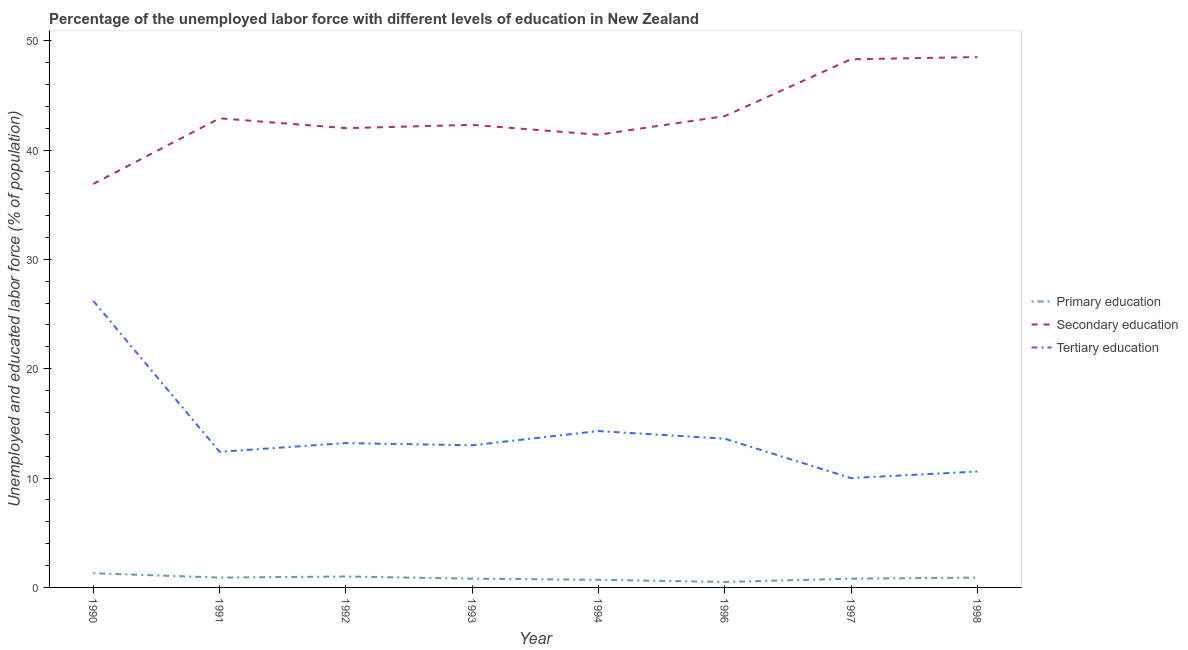Does the line corresponding to percentage of labor force who received primary education intersect with the line corresponding to percentage of labor force who received tertiary education?
Offer a very short reply. No. What is the percentage of labor force who received secondary education in 1991?
Your response must be concise. 42.9. Across all years, what is the maximum percentage of labor force who received tertiary education?
Keep it short and to the point. 26.2. In which year was the percentage of labor force who received secondary education maximum?
Provide a short and direct response. 1998. What is the total percentage of labor force who received tertiary education in the graph?
Give a very brief answer. 113.3. What is the difference between the percentage of labor force who received primary education in 1993 and that in 1994?
Your answer should be compact. 0.1. What is the difference between the percentage of labor force who received tertiary education in 1991 and the percentage of labor force who received secondary education in 1998?
Provide a short and direct response. -36.1. What is the average percentage of labor force who received tertiary education per year?
Provide a short and direct response. 14.16. In the year 1994, what is the difference between the percentage of labor force who received primary education and percentage of labor force who received tertiary education?
Your answer should be compact. -13.6. In how many years, is the percentage of labor force who received tertiary education greater than 24 %?
Make the answer very short. 1. What is the ratio of the percentage of labor force who received tertiary education in 1991 to that in 1997?
Your answer should be very brief. 1.24. Is the difference between the percentage of labor force who received secondary education in 1992 and 1996 greater than the difference between the percentage of labor force who received tertiary education in 1992 and 1996?
Provide a short and direct response. No. What is the difference between the highest and the second highest percentage of labor force who received primary education?
Ensure brevity in your answer.  0.3. What is the difference between the highest and the lowest percentage of labor force who received tertiary education?
Your answer should be compact. 16.2. Is the sum of the percentage of labor force who received tertiary education in 1992 and 1997 greater than the maximum percentage of labor force who received secondary education across all years?
Give a very brief answer. No. Does the percentage of labor force who received tertiary education monotonically increase over the years?
Your answer should be very brief. No. Is the percentage of labor force who received tertiary education strictly less than the percentage of labor force who received secondary education over the years?
Your answer should be very brief. Yes. How many years are there in the graph?
Your answer should be very brief. 8. What is the difference between two consecutive major ticks on the Y-axis?
Give a very brief answer. 10. Are the values on the major ticks of Y-axis written in scientific E-notation?
Offer a terse response. No. Does the graph contain grids?
Your answer should be very brief. No. How are the legend labels stacked?
Give a very brief answer. Vertical. What is the title of the graph?
Your response must be concise. Percentage of the unemployed labor force with different levels of education in New Zealand. Does "Errors" appear as one of the legend labels in the graph?
Provide a short and direct response. No. What is the label or title of the Y-axis?
Offer a very short reply. Unemployed and educated labor force (% of population). What is the Unemployed and educated labor force (% of population) of Primary education in 1990?
Give a very brief answer. 1.3. What is the Unemployed and educated labor force (% of population) in Secondary education in 1990?
Offer a terse response. 36.9. What is the Unemployed and educated labor force (% of population) in Tertiary education in 1990?
Offer a very short reply. 26.2. What is the Unemployed and educated labor force (% of population) of Primary education in 1991?
Ensure brevity in your answer.  0.9. What is the Unemployed and educated labor force (% of population) in Secondary education in 1991?
Make the answer very short. 42.9. What is the Unemployed and educated labor force (% of population) of Tertiary education in 1991?
Keep it short and to the point. 12.4. What is the Unemployed and educated labor force (% of population) of Primary education in 1992?
Give a very brief answer. 1. What is the Unemployed and educated labor force (% of population) of Tertiary education in 1992?
Provide a succinct answer. 13.2. What is the Unemployed and educated labor force (% of population) in Primary education in 1993?
Give a very brief answer. 0.8. What is the Unemployed and educated labor force (% of population) of Secondary education in 1993?
Your answer should be compact. 42.3. What is the Unemployed and educated labor force (% of population) of Tertiary education in 1993?
Offer a terse response. 13. What is the Unemployed and educated labor force (% of population) in Primary education in 1994?
Make the answer very short. 0.7. What is the Unemployed and educated labor force (% of population) in Secondary education in 1994?
Your response must be concise. 41.4. What is the Unemployed and educated labor force (% of population) of Tertiary education in 1994?
Give a very brief answer. 14.3. What is the Unemployed and educated labor force (% of population) in Secondary education in 1996?
Offer a terse response. 43.1. What is the Unemployed and educated labor force (% of population) in Tertiary education in 1996?
Make the answer very short. 13.6. What is the Unemployed and educated labor force (% of population) of Primary education in 1997?
Your response must be concise. 0.8. What is the Unemployed and educated labor force (% of population) in Secondary education in 1997?
Provide a short and direct response. 48.3. What is the Unemployed and educated labor force (% of population) in Tertiary education in 1997?
Keep it short and to the point. 10. What is the Unemployed and educated labor force (% of population) in Primary education in 1998?
Your answer should be very brief. 0.9. What is the Unemployed and educated labor force (% of population) of Secondary education in 1998?
Your answer should be compact. 48.5. What is the Unemployed and educated labor force (% of population) of Tertiary education in 1998?
Give a very brief answer. 10.6. Across all years, what is the maximum Unemployed and educated labor force (% of population) in Primary education?
Your answer should be compact. 1.3. Across all years, what is the maximum Unemployed and educated labor force (% of population) of Secondary education?
Make the answer very short. 48.5. Across all years, what is the maximum Unemployed and educated labor force (% of population) of Tertiary education?
Your response must be concise. 26.2. Across all years, what is the minimum Unemployed and educated labor force (% of population) in Primary education?
Provide a succinct answer. 0.5. Across all years, what is the minimum Unemployed and educated labor force (% of population) of Secondary education?
Give a very brief answer. 36.9. What is the total Unemployed and educated labor force (% of population) in Secondary education in the graph?
Your answer should be very brief. 345.4. What is the total Unemployed and educated labor force (% of population) of Tertiary education in the graph?
Your response must be concise. 113.3. What is the difference between the Unemployed and educated labor force (% of population) in Secondary education in 1990 and that in 1991?
Your answer should be compact. -6. What is the difference between the Unemployed and educated labor force (% of population) in Secondary education in 1990 and that in 1992?
Provide a succinct answer. -5.1. What is the difference between the Unemployed and educated labor force (% of population) of Primary education in 1990 and that in 1993?
Make the answer very short. 0.5. What is the difference between the Unemployed and educated labor force (% of population) in Secondary education in 1990 and that in 1993?
Provide a succinct answer. -5.4. What is the difference between the Unemployed and educated labor force (% of population) of Secondary education in 1990 and that in 1994?
Ensure brevity in your answer.  -4.5. What is the difference between the Unemployed and educated labor force (% of population) of Tertiary education in 1990 and that in 1994?
Your answer should be very brief. 11.9. What is the difference between the Unemployed and educated labor force (% of population) of Tertiary education in 1990 and that in 1997?
Make the answer very short. 16.2. What is the difference between the Unemployed and educated labor force (% of population) in Primary education in 1991 and that in 1992?
Your response must be concise. -0.1. What is the difference between the Unemployed and educated labor force (% of population) of Secondary education in 1991 and that in 1992?
Make the answer very short. 0.9. What is the difference between the Unemployed and educated labor force (% of population) of Primary education in 1991 and that in 1994?
Ensure brevity in your answer.  0.2. What is the difference between the Unemployed and educated labor force (% of population) in Secondary education in 1991 and that in 1994?
Provide a short and direct response. 1.5. What is the difference between the Unemployed and educated labor force (% of population) in Tertiary education in 1991 and that in 1994?
Your answer should be very brief. -1.9. What is the difference between the Unemployed and educated labor force (% of population) of Primary education in 1991 and that in 1996?
Offer a very short reply. 0.4. What is the difference between the Unemployed and educated labor force (% of population) of Primary education in 1991 and that in 1997?
Offer a terse response. 0.1. What is the difference between the Unemployed and educated labor force (% of population) in Secondary education in 1991 and that in 1997?
Provide a short and direct response. -5.4. What is the difference between the Unemployed and educated labor force (% of population) of Tertiary education in 1991 and that in 1997?
Ensure brevity in your answer.  2.4. What is the difference between the Unemployed and educated labor force (% of population) in Primary education in 1991 and that in 1998?
Your answer should be compact. 0. What is the difference between the Unemployed and educated labor force (% of population) in Primary education in 1992 and that in 1993?
Your answer should be very brief. 0.2. What is the difference between the Unemployed and educated labor force (% of population) of Secondary education in 1992 and that in 1993?
Your answer should be very brief. -0.3. What is the difference between the Unemployed and educated labor force (% of population) in Tertiary education in 1992 and that in 1993?
Offer a very short reply. 0.2. What is the difference between the Unemployed and educated labor force (% of population) in Primary education in 1992 and that in 1994?
Your answer should be compact. 0.3. What is the difference between the Unemployed and educated labor force (% of population) in Tertiary education in 1992 and that in 1994?
Make the answer very short. -1.1. What is the difference between the Unemployed and educated labor force (% of population) in Tertiary education in 1992 and that in 1996?
Your response must be concise. -0.4. What is the difference between the Unemployed and educated labor force (% of population) of Primary education in 1992 and that in 1997?
Your answer should be compact. 0.2. What is the difference between the Unemployed and educated labor force (% of population) in Secondary education in 1992 and that in 1997?
Provide a short and direct response. -6.3. What is the difference between the Unemployed and educated labor force (% of population) in Tertiary education in 1992 and that in 1997?
Your response must be concise. 3.2. What is the difference between the Unemployed and educated labor force (% of population) of Tertiary education in 1992 and that in 1998?
Keep it short and to the point. 2.6. What is the difference between the Unemployed and educated labor force (% of population) in Primary education in 1993 and that in 1994?
Your answer should be compact. 0.1. What is the difference between the Unemployed and educated labor force (% of population) in Primary education in 1993 and that in 1996?
Your answer should be very brief. 0.3. What is the difference between the Unemployed and educated labor force (% of population) in Secondary education in 1993 and that in 1996?
Give a very brief answer. -0.8. What is the difference between the Unemployed and educated labor force (% of population) of Tertiary education in 1993 and that in 1996?
Give a very brief answer. -0.6. What is the difference between the Unemployed and educated labor force (% of population) of Tertiary education in 1993 and that in 1998?
Provide a succinct answer. 2.4. What is the difference between the Unemployed and educated labor force (% of population) in Primary education in 1994 and that in 1996?
Your answer should be compact. 0.2. What is the difference between the Unemployed and educated labor force (% of population) of Tertiary education in 1994 and that in 1996?
Provide a short and direct response. 0.7. What is the difference between the Unemployed and educated labor force (% of population) in Secondary education in 1994 and that in 1997?
Your response must be concise. -6.9. What is the difference between the Unemployed and educated labor force (% of population) in Primary education in 1996 and that in 1997?
Offer a terse response. -0.3. What is the difference between the Unemployed and educated labor force (% of population) in Tertiary education in 1996 and that in 1997?
Offer a very short reply. 3.6. What is the difference between the Unemployed and educated labor force (% of population) in Primary education in 1996 and that in 1998?
Offer a terse response. -0.4. What is the difference between the Unemployed and educated labor force (% of population) in Secondary education in 1997 and that in 1998?
Provide a succinct answer. -0.2. What is the difference between the Unemployed and educated labor force (% of population) of Tertiary education in 1997 and that in 1998?
Keep it short and to the point. -0.6. What is the difference between the Unemployed and educated labor force (% of population) of Primary education in 1990 and the Unemployed and educated labor force (% of population) of Secondary education in 1991?
Your answer should be compact. -41.6. What is the difference between the Unemployed and educated labor force (% of population) of Primary education in 1990 and the Unemployed and educated labor force (% of population) of Secondary education in 1992?
Ensure brevity in your answer.  -40.7. What is the difference between the Unemployed and educated labor force (% of population) in Primary education in 1990 and the Unemployed and educated labor force (% of population) in Tertiary education in 1992?
Your answer should be very brief. -11.9. What is the difference between the Unemployed and educated labor force (% of population) in Secondary education in 1990 and the Unemployed and educated labor force (% of population) in Tertiary education in 1992?
Offer a very short reply. 23.7. What is the difference between the Unemployed and educated labor force (% of population) of Primary education in 1990 and the Unemployed and educated labor force (% of population) of Secondary education in 1993?
Provide a succinct answer. -41. What is the difference between the Unemployed and educated labor force (% of population) of Secondary education in 1990 and the Unemployed and educated labor force (% of population) of Tertiary education in 1993?
Make the answer very short. 23.9. What is the difference between the Unemployed and educated labor force (% of population) in Primary education in 1990 and the Unemployed and educated labor force (% of population) in Secondary education in 1994?
Keep it short and to the point. -40.1. What is the difference between the Unemployed and educated labor force (% of population) in Secondary education in 1990 and the Unemployed and educated labor force (% of population) in Tertiary education in 1994?
Offer a terse response. 22.6. What is the difference between the Unemployed and educated labor force (% of population) of Primary education in 1990 and the Unemployed and educated labor force (% of population) of Secondary education in 1996?
Keep it short and to the point. -41.8. What is the difference between the Unemployed and educated labor force (% of population) of Secondary education in 1990 and the Unemployed and educated labor force (% of population) of Tertiary education in 1996?
Your answer should be very brief. 23.3. What is the difference between the Unemployed and educated labor force (% of population) in Primary education in 1990 and the Unemployed and educated labor force (% of population) in Secondary education in 1997?
Provide a short and direct response. -47. What is the difference between the Unemployed and educated labor force (% of population) in Primary education in 1990 and the Unemployed and educated labor force (% of population) in Tertiary education in 1997?
Your response must be concise. -8.7. What is the difference between the Unemployed and educated labor force (% of population) in Secondary education in 1990 and the Unemployed and educated labor force (% of population) in Tertiary education in 1997?
Ensure brevity in your answer.  26.9. What is the difference between the Unemployed and educated labor force (% of population) of Primary education in 1990 and the Unemployed and educated labor force (% of population) of Secondary education in 1998?
Keep it short and to the point. -47.2. What is the difference between the Unemployed and educated labor force (% of population) of Primary education in 1990 and the Unemployed and educated labor force (% of population) of Tertiary education in 1998?
Ensure brevity in your answer.  -9.3. What is the difference between the Unemployed and educated labor force (% of population) in Secondary education in 1990 and the Unemployed and educated labor force (% of population) in Tertiary education in 1998?
Provide a succinct answer. 26.3. What is the difference between the Unemployed and educated labor force (% of population) of Primary education in 1991 and the Unemployed and educated labor force (% of population) of Secondary education in 1992?
Give a very brief answer. -41.1. What is the difference between the Unemployed and educated labor force (% of population) in Primary education in 1991 and the Unemployed and educated labor force (% of population) in Tertiary education in 1992?
Offer a terse response. -12.3. What is the difference between the Unemployed and educated labor force (% of population) of Secondary education in 1991 and the Unemployed and educated labor force (% of population) of Tertiary education in 1992?
Your answer should be very brief. 29.7. What is the difference between the Unemployed and educated labor force (% of population) in Primary education in 1991 and the Unemployed and educated labor force (% of population) in Secondary education in 1993?
Give a very brief answer. -41.4. What is the difference between the Unemployed and educated labor force (% of population) of Secondary education in 1991 and the Unemployed and educated labor force (% of population) of Tertiary education in 1993?
Provide a short and direct response. 29.9. What is the difference between the Unemployed and educated labor force (% of population) of Primary education in 1991 and the Unemployed and educated labor force (% of population) of Secondary education in 1994?
Make the answer very short. -40.5. What is the difference between the Unemployed and educated labor force (% of population) of Secondary education in 1991 and the Unemployed and educated labor force (% of population) of Tertiary education in 1994?
Give a very brief answer. 28.6. What is the difference between the Unemployed and educated labor force (% of population) of Primary education in 1991 and the Unemployed and educated labor force (% of population) of Secondary education in 1996?
Your answer should be compact. -42.2. What is the difference between the Unemployed and educated labor force (% of population) of Primary education in 1991 and the Unemployed and educated labor force (% of population) of Tertiary education in 1996?
Offer a very short reply. -12.7. What is the difference between the Unemployed and educated labor force (% of population) of Secondary education in 1991 and the Unemployed and educated labor force (% of population) of Tertiary education in 1996?
Give a very brief answer. 29.3. What is the difference between the Unemployed and educated labor force (% of population) in Primary education in 1991 and the Unemployed and educated labor force (% of population) in Secondary education in 1997?
Offer a terse response. -47.4. What is the difference between the Unemployed and educated labor force (% of population) in Secondary education in 1991 and the Unemployed and educated labor force (% of population) in Tertiary education in 1997?
Your answer should be compact. 32.9. What is the difference between the Unemployed and educated labor force (% of population) of Primary education in 1991 and the Unemployed and educated labor force (% of population) of Secondary education in 1998?
Provide a short and direct response. -47.6. What is the difference between the Unemployed and educated labor force (% of population) in Primary education in 1991 and the Unemployed and educated labor force (% of population) in Tertiary education in 1998?
Your answer should be very brief. -9.7. What is the difference between the Unemployed and educated labor force (% of population) in Secondary education in 1991 and the Unemployed and educated labor force (% of population) in Tertiary education in 1998?
Provide a succinct answer. 32.3. What is the difference between the Unemployed and educated labor force (% of population) of Primary education in 1992 and the Unemployed and educated labor force (% of population) of Secondary education in 1993?
Your answer should be compact. -41.3. What is the difference between the Unemployed and educated labor force (% of population) in Primary education in 1992 and the Unemployed and educated labor force (% of population) in Tertiary education in 1993?
Provide a short and direct response. -12. What is the difference between the Unemployed and educated labor force (% of population) of Secondary education in 1992 and the Unemployed and educated labor force (% of population) of Tertiary education in 1993?
Make the answer very short. 29. What is the difference between the Unemployed and educated labor force (% of population) in Primary education in 1992 and the Unemployed and educated labor force (% of population) in Secondary education in 1994?
Offer a very short reply. -40.4. What is the difference between the Unemployed and educated labor force (% of population) of Secondary education in 1992 and the Unemployed and educated labor force (% of population) of Tertiary education in 1994?
Keep it short and to the point. 27.7. What is the difference between the Unemployed and educated labor force (% of population) in Primary education in 1992 and the Unemployed and educated labor force (% of population) in Secondary education in 1996?
Provide a short and direct response. -42.1. What is the difference between the Unemployed and educated labor force (% of population) of Primary education in 1992 and the Unemployed and educated labor force (% of population) of Tertiary education in 1996?
Offer a terse response. -12.6. What is the difference between the Unemployed and educated labor force (% of population) of Secondary education in 1992 and the Unemployed and educated labor force (% of population) of Tertiary education in 1996?
Ensure brevity in your answer.  28.4. What is the difference between the Unemployed and educated labor force (% of population) of Primary education in 1992 and the Unemployed and educated labor force (% of population) of Secondary education in 1997?
Ensure brevity in your answer.  -47.3. What is the difference between the Unemployed and educated labor force (% of population) of Primary education in 1992 and the Unemployed and educated labor force (% of population) of Tertiary education in 1997?
Your answer should be compact. -9. What is the difference between the Unemployed and educated labor force (% of population) of Primary education in 1992 and the Unemployed and educated labor force (% of population) of Secondary education in 1998?
Your answer should be compact. -47.5. What is the difference between the Unemployed and educated labor force (% of population) of Primary education in 1992 and the Unemployed and educated labor force (% of population) of Tertiary education in 1998?
Offer a very short reply. -9.6. What is the difference between the Unemployed and educated labor force (% of population) of Secondary education in 1992 and the Unemployed and educated labor force (% of population) of Tertiary education in 1998?
Offer a very short reply. 31.4. What is the difference between the Unemployed and educated labor force (% of population) in Primary education in 1993 and the Unemployed and educated labor force (% of population) in Secondary education in 1994?
Your answer should be compact. -40.6. What is the difference between the Unemployed and educated labor force (% of population) of Secondary education in 1993 and the Unemployed and educated labor force (% of population) of Tertiary education in 1994?
Offer a very short reply. 28. What is the difference between the Unemployed and educated labor force (% of population) in Primary education in 1993 and the Unemployed and educated labor force (% of population) in Secondary education in 1996?
Ensure brevity in your answer.  -42.3. What is the difference between the Unemployed and educated labor force (% of population) in Primary education in 1993 and the Unemployed and educated labor force (% of population) in Tertiary education in 1996?
Offer a terse response. -12.8. What is the difference between the Unemployed and educated labor force (% of population) in Secondary education in 1993 and the Unemployed and educated labor force (% of population) in Tertiary education in 1996?
Keep it short and to the point. 28.7. What is the difference between the Unemployed and educated labor force (% of population) in Primary education in 1993 and the Unemployed and educated labor force (% of population) in Secondary education in 1997?
Provide a short and direct response. -47.5. What is the difference between the Unemployed and educated labor force (% of population) in Secondary education in 1993 and the Unemployed and educated labor force (% of population) in Tertiary education in 1997?
Provide a short and direct response. 32.3. What is the difference between the Unemployed and educated labor force (% of population) of Primary education in 1993 and the Unemployed and educated labor force (% of population) of Secondary education in 1998?
Ensure brevity in your answer.  -47.7. What is the difference between the Unemployed and educated labor force (% of population) of Secondary education in 1993 and the Unemployed and educated labor force (% of population) of Tertiary education in 1998?
Your answer should be compact. 31.7. What is the difference between the Unemployed and educated labor force (% of population) in Primary education in 1994 and the Unemployed and educated labor force (% of population) in Secondary education in 1996?
Make the answer very short. -42.4. What is the difference between the Unemployed and educated labor force (% of population) of Secondary education in 1994 and the Unemployed and educated labor force (% of population) of Tertiary education in 1996?
Make the answer very short. 27.8. What is the difference between the Unemployed and educated labor force (% of population) of Primary education in 1994 and the Unemployed and educated labor force (% of population) of Secondary education in 1997?
Your answer should be very brief. -47.6. What is the difference between the Unemployed and educated labor force (% of population) of Primary education in 1994 and the Unemployed and educated labor force (% of population) of Tertiary education in 1997?
Offer a terse response. -9.3. What is the difference between the Unemployed and educated labor force (% of population) in Secondary education in 1994 and the Unemployed and educated labor force (% of population) in Tertiary education in 1997?
Offer a terse response. 31.4. What is the difference between the Unemployed and educated labor force (% of population) in Primary education in 1994 and the Unemployed and educated labor force (% of population) in Secondary education in 1998?
Your response must be concise. -47.8. What is the difference between the Unemployed and educated labor force (% of population) of Primary education in 1994 and the Unemployed and educated labor force (% of population) of Tertiary education in 1998?
Provide a succinct answer. -9.9. What is the difference between the Unemployed and educated labor force (% of population) of Secondary education in 1994 and the Unemployed and educated labor force (% of population) of Tertiary education in 1998?
Your response must be concise. 30.8. What is the difference between the Unemployed and educated labor force (% of population) of Primary education in 1996 and the Unemployed and educated labor force (% of population) of Secondary education in 1997?
Your response must be concise. -47.8. What is the difference between the Unemployed and educated labor force (% of population) in Secondary education in 1996 and the Unemployed and educated labor force (% of population) in Tertiary education in 1997?
Your answer should be compact. 33.1. What is the difference between the Unemployed and educated labor force (% of population) in Primary education in 1996 and the Unemployed and educated labor force (% of population) in Secondary education in 1998?
Your response must be concise. -48. What is the difference between the Unemployed and educated labor force (% of population) of Primary education in 1996 and the Unemployed and educated labor force (% of population) of Tertiary education in 1998?
Keep it short and to the point. -10.1. What is the difference between the Unemployed and educated labor force (% of population) in Secondary education in 1996 and the Unemployed and educated labor force (% of population) in Tertiary education in 1998?
Your response must be concise. 32.5. What is the difference between the Unemployed and educated labor force (% of population) in Primary education in 1997 and the Unemployed and educated labor force (% of population) in Secondary education in 1998?
Provide a succinct answer. -47.7. What is the difference between the Unemployed and educated labor force (% of population) of Primary education in 1997 and the Unemployed and educated labor force (% of population) of Tertiary education in 1998?
Offer a terse response. -9.8. What is the difference between the Unemployed and educated labor force (% of population) in Secondary education in 1997 and the Unemployed and educated labor force (% of population) in Tertiary education in 1998?
Your answer should be compact. 37.7. What is the average Unemployed and educated labor force (% of population) in Primary education per year?
Provide a short and direct response. 0.86. What is the average Unemployed and educated labor force (% of population) in Secondary education per year?
Provide a short and direct response. 43.17. What is the average Unemployed and educated labor force (% of population) in Tertiary education per year?
Offer a very short reply. 14.16. In the year 1990, what is the difference between the Unemployed and educated labor force (% of population) of Primary education and Unemployed and educated labor force (% of population) of Secondary education?
Keep it short and to the point. -35.6. In the year 1990, what is the difference between the Unemployed and educated labor force (% of population) in Primary education and Unemployed and educated labor force (% of population) in Tertiary education?
Your answer should be very brief. -24.9. In the year 1990, what is the difference between the Unemployed and educated labor force (% of population) in Secondary education and Unemployed and educated labor force (% of population) in Tertiary education?
Provide a short and direct response. 10.7. In the year 1991, what is the difference between the Unemployed and educated labor force (% of population) of Primary education and Unemployed and educated labor force (% of population) of Secondary education?
Provide a short and direct response. -42. In the year 1991, what is the difference between the Unemployed and educated labor force (% of population) of Primary education and Unemployed and educated labor force (% of population) of Tertiary education?
Make the answer very short. -11.5. In the year 1991, what is the difference between the Unemployed and educated labor force (% of population) in Secondary education and Unemployed and educated labor force (% of population) in Tertiary education?
Keep it short and to the point. 30.5. In the year 1992, what is the difference between the Unemployed and educated labor force (% of population) in Primary education and Unemployed and educated labor force (% of population) in Secondary education?
Your answer should be compact. -41. In the year 1992, what is the difference between the Unemployed and educated labor force (% of population) in Primary education and Unemployed and educated labor force (% of population) in Tertiary education?
Give a very brief answer. -12.2. In the year 1992, what is the difference between the Unemployed and educated labor force (% of population) of Secondary education and Unemployed and educated labor force (% of population) of Tertiary education?
Give a very brief answer. 28.8. In the year 1993, what is the difference between the Unemployed and educated labor force (% of population) in Primary education and Unemployed and educated labor force (% of population) in Secondary education?
Offer a very short reply. -41.5. In the year 1993, what is the difference between the Unemployed and educated labor force (% of population) in Primary education and Unemployed and educated labor force (% of population) in Tertiary education?
Your response must be concise. -12.2. In the year 1993, what is the difference between the Unemployed and educated labor force (% of population) of Secondary education and Unemployed and educated labor force (% of population) of Tertiary education?
Give a very brief answer. 29.3. In the year 1994, what is the difference between the Unemployed and educated labor force (% of population) of Primary education and Unemployed and educated labor force (% of population) of Secondary education?
Offer a very short reply. -40.7. In the year 1994, what is the difference between the Unemployed and educated labor force (% of population) in Secondary education and Unemployed and educated labor force (% of population) in Tertiary education?
Your answer should be very brief. 27.1. In the year 1996, what is the difference between the Unemployed and educated labor force (% of population) of Primary education and Unemployed and educated labor force (% of population) of Secondary education?
Your answer should be compact. -42.6. In the year 1996, what is the difference between the Unemployed and educated labor force (% of population) of Secondary education and Unemployed and educated labor force (% of population) of Tertiary education?
Your response must be concise. 29.5. In the year 1997, what is the difference between the Unemployed and educated labor force (% of population) in Primary education and Unemployed and educated labor force (% of population) in Secondary education?
Offer a terse response. -47.5. In the year 1997, what is the difference between the Unemployed and educated labor force (% of population) in Secondary education and Unemployed and educated labor force (% of population) in Tertiary education?
Make the answer very short. 38.3. In the year 1998, what is the difference between the Unemployed and educated labor force (% of population) of Primary education and Unemployed and educated labor force (% of population) of Secondary education?
Your answer should be compact. -47.6. In the year 1998, what is the difference between the Unemployed and educated labor force (% of population) in Secondary education and Unemployed and educated labor force (% of population) in Tertiary education?
Keep it short and to the point. 37.9. What is the ratio of the Unemployed and educated labor force (% of population) of Primary education in 1990 to that in 1991?
Keep it short and to the point. 1.44. What is the ratio of the Unemployed and educated labor force (% of population) in Secondary education in 1990 to that in 1991?
Your response must be concise. 0.86. What is the ratio of the Unemployed and educated labor force (% of population) in Tertiary education in 1990 to that in 1991?
Keep it short and to the point. 2.11. What is the ratio of the Unemployed and educated labor force (% of population) in Primary education in 1990 to that in 1992?
Your response must be concise. 1.3. What is the ratio of the Unemployed and educated labor force (% of population) of Secondary education in 1990 to that in 1992?
Your answer should be compact. 0.88. What is the ratio of the Unemployed and educated labor force (% of population) in Tertiary education in 1990 to that in 1992?
Your response must be concise. 1.98. What is the ratio of the Unemployed and educated labor force (% of population) of Primary education in 1990 to that in 1993?
Provide a short and direct response. 1.62. What is the ratio of the Unemployed and educated labor force (% of population) in Secondary education in 1990 to that in 1993?
Offer a very short reply. 0.87. What is the ratio of the Unemployed and educated labor force (% of population) in Tertiary education in 1990 to that in 1993?
Your response must be concise. 2.02. What is the ratio of the Unemployed and educated labor force (% of population) of Primary education in 1990 to that in 1994?
Offer a terse response. 1.86. What is the ratio of the Unemployed and educated labor force (% of population) of Secondary education in 1990 to that in 1994?
Your answer should be very brief. 0.89. What is the ratio of the Unemployed and educated labor force (% of population) of Tertiary education in 1990 to that in 1994?
Make the answer very short. 1.83. What is the ratio of the Unemployed and educated labor force (% of population) in Secondary education in 1990 to that in 1996?
Your answer should be compact. 0.86. What is the ratio of the Unemployed and educated labor force (% of population) in Tertiary education in 1990 to that in 1996?
Your response must be concise. 1.93. What is the ratio of the Unemployed and educated labor force (% of population) of Primary education in 1990 to that in 1997?
Offer a very short reply. 1.62. What is the ratio of the Unemployed and educated labor force (% of population) of Secondary education in 1990 to that in 1997?
Your response must be concise. 0.76. What is the ratio of the Unemployed and educated labor force (% of population) of Tertiary education in 1990 to that in 1997?
Offer a very short reply. 2.62. What is the ratio of the Unemployed and educated labor force (% of population) in Primary education in 1990 to that in 1998?
Offer a very short reply. 1.44. What is the ratio of the Unemployed and educated labor force (% of population) in Secondary education in 1990 to that in 1998?
Provide a short and direct response. 0.76. What is the ratio of the Unemployed and educated labor force (% of population) in Tertiary education in 1990 to that in 1998?
Offer a very short reply. 2.47. What is the ratio of the Unemployed and educated labor force (% of population) in Secondary education in 1991 to that in 1992?
Your response must be concise. 1.02. What is the ratio of the Unemployed and educated labor force (% of population) of Tertiary education in 1991 to that in 1992?
Offer a very short reply. 0.94. What is the ratio of the Unemployed and educated labor force (% of population) in Secondary education in 1991 to that in 1993?
Provide a succinct answer. 1.01. What is the ratio of the Unemployed and educated labor force (% of population) in Tertiary education in 1991 to that in 1993?
Your response must be concise. 0.95. What is the ratio of the Unemployed and educated labor force (% of population) of Primary education in 1991 to that in 1994?
Ensure brevity in your answer.  1.29. What is the ratio of the Unemployed and educated labor force (% of population) in Secondary education in 1991 to that in 1994?
Provide a short and direct response. 1.04. What is the ratio of the Unemployed and educated labor force (% of population) in Tertiary education in 1991 to that in 1994?
Make the answer very short. 0.87. What is the ratio of the Unemployed and educated labor force (% of population) in Tertiary education in 1991 to that in 1996?
Offer a terse response. 0.91. What is the ratio of the Unemployed and educated labor force (% of population) in Secondary education in 1991 to that in 1997?
Your response must be concise. 0.89. What is the ratio of the Unemployed and educated labor force (% of population) of Tertiary education in 1991 to that in 1997?
Provide a short and direct response. 1.24. What is the ratio of the Unemployed and educated labor force (% of population) of Primary education in 1991 to that in 1998?
Offer a very short reply. 1. What is the ratio of the Unemployed and educated labor force (% of population) in Secondary education in 1991 to that in 1998?
Offer a terse response. 0.88. What is the ratio of the Unemployed and educated labor force (% of population) of Tertiary education in 1991 to that in 1998?
Your answer should be compact. 1.17. What is the ratio of the Unemployed and educated labor force (% of population) of Primary education in 1992 to that in 1993?
Your response must be concise. 1.25. What is the ratio of the Unemployed and educated labor force (% of population) in Secondary education in 1992 to that in 1993?
Provide a succinct answer. 0.99. What is the ratio of the Unemployed and educated labor force (% of population) in Tertiary education in 1992 to that in 1993?
Give a very brief answer. 1.02. What is the ratio of the Unemployed and educated labor force (% of population) of Primary education in 1992 to that in 1994?
Offer a very short reply. 1.43. What is the ratio of the Unemployed and educated labor force (% of population) of Secondary education in 1992 to that in 1994?
Provide a succinct answer. 1.01. What is the ratio of the Unemployed and educated labor force (% of population) of Tertiary education in 1992 to that in 1994?
Provide a short and direct response. 0.92. What is the ratio of the Unemployed and educated labor force (% of population) of Secondary education in 1992 to that in 1996?
Keep it short and to the point. 0.97. What is the ratio of the Unemployed and educated labor force (% of population) in Tertiary education in 1992 to that in 1996?
Your response must be concise. 0.97. What is the ratio of the Unemployed and educated labor force (% of population) of Primary education in 1992 to that in 1997?
Your response must be concise. 1.25. What is the ratio of the Unemployed and educated labor force (% of population) in Secondary education in 1992 to that in 1997?
Offer a very short reply. 0.87. What is the ratio of the Unemployed and educated labor force (% of population) of Tertiary education in 1992 to that in 1997?
Keep it short and to the point. 1.32. What is the ratio of the Unemployed and educated labor force (% of population) in Secondary education in 1992 to that in 1998?
Provide a succinct answer. 0.87. What is the ratio of the Unemployed and educated labor force (% of population) in Tertiary education in 1992 to that in 1998?
Provide a succinct answer. 1.25. What is the ratio of the Unemployed and educated labor force (% of population) in Primary education in 1993 to that in 1994?
Give a very brief answer. 1.14. What is the ratio of the Unemployed and educated labor force (% of population) of Secondary education in 1993 to that in 1994?
Keep it short and to the point. 1.02. What is the ratio of the Unemployed and educated labor force (% of population) in Primary education in 1993 to that in 1996?
Your answer should be very brief. 1.6. What is the ratio of the Unemployed and educated labor force (% of population) in Secondary education in 1993 to that in 1996?
Ensure brevity in your answer.  0.98. What is the ratio of the Unemployed and educated labor force (% of population) in Tertiary education in 1993 to that in 1996?
Provide a succinct answer. 0.96. What is the ratio of the Unemployed and educated labor force (% of population) of Secondary education in 1993 to that in 1997?
Give a very brief answer. 0.88. What is the ratio of the Unemployed and educated labor force (% of population) in Primary education in 1993 to that in 1998?
Give a very brief answer. 0.89. What is the ratio of the Unemployed and educated labor force (% of population) of Secondary education in 1993 to that in 1998?
Your answer should be very brief. 0.87. What is the ratio of the Unemployed and educated labor force (% of population) of Tertiary education in 1993 to that in 1998?
Offer a terse response. 1.23. What is the ratio of the Unemployed and educated labor force (% of population) of Primary education in 1994 to that in 1996?
Provide a short and direct response. 1.4. What is the ratio of the Unemployed and educated labor force (% of population) of Secondary education in 1994 to that in 1996?
Offer a very short reply. 0.96. What is the ratio of the Unemployed and educated labor force (% of population) of Tertiary education in 1994 to that in 1996?
Offer a very short reply. 1.05. What is the ratio of the Unemployed and educated labor force (% of population) in Tertiary education in 1994 to that in 1997?
Offer a terse response. 1.43. What is the ratio of the Unemployed and educated labor force (% of population) of Secondary education in 1994 to that in 1998?
Give a very brief answer. 0.85. What is the ratio of the Unemployed and educated labor force (% of population) of Tertiary education in 1994 to that in 1998?
Offer a very short reply. 1.35. What is the ratio of the Unemployed and educated labor force (% of population) of Primary education in 1996 to that in 1997?
Provide a short and direct response. 0.62. What is the ratio of the Unemployed and educated labor force (% of population) in Secondary education in 1996 to that in 1997?
Make the answer very short. 0.89. What is the ratio of the Unemployed and educated labor force (% of population) of Tertiary education in 1996 to that in 1997?
Your answer should be compact. 1.36. What is the ratio of the Unemployed and educated labor force (% of population) in Primary education in 1996 to that in 1998?
Offer a terse response. 0.56. What is the ratio of the Unemployed and educated labor force (% of population) of Secondary education in 1996 to that in 1998?
Ensure brevity in your answer.  0.89. What is the ratio of the Unemployed and educated labor force (% of population) in Tertiary education in 1996 to that in 1998?
Your answer should be very brief. 1.28. What is the ratio of the Unemployed and educated labor force (% of population) in Tertiary education in 1997 to that in 1998?
Ensure brevity in your answer.  0.94. What is the difference between the highest and the lowest Unemployed and educated labor force (% of population) of Primary education?
Ensure brevity in your answer.  0.8. 